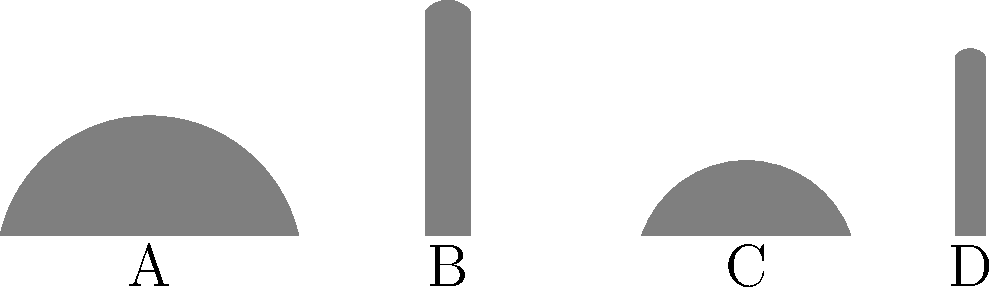Which of the silhouettes (A, B, C, or D) most likely represents a traditional Islamic mosque architecture? To identify the silhouette that most likely represents a traditional Islamic mosque architecture, let's analyze each shape:

1. Shape A: This is a large dome structure, which is a common feature in Islamic architecture. Domes are often used to cover the main prayer hall in mosques.

2. Shape B: This is a tall, slender structure with a small dome on top. This silhouette closely resembles a minaret, which is a distinctive feature of mosque architecture. Minarets are tall towers used for the call to prayer.

3. Shape C: This is a smaller dome structure, similar to A but not as prominent. While domes are common in Islamic architecture, this one alone doesn't strongly indicate a mosque.

4. Shape D: This is another tall, slender structure similar to B, but slightly shorter and with a smaller dome on top. This also resembles a minaret.

The combination of a large dome (A) and a minaret (B or D) is most characteristic of traditional Islamic mosque architecture. However, since we can only choose one silhouette, the minaret (B) is the most distinctive and recognizable feature of a mosque.

Minarets are unique to Islamic religious architecture and are not typically found in Christian or other religious buildings in the Middle East. Therefore, the silhouette that most likely represents a traditional Islamic mosque architecture is B.
Answer: B 